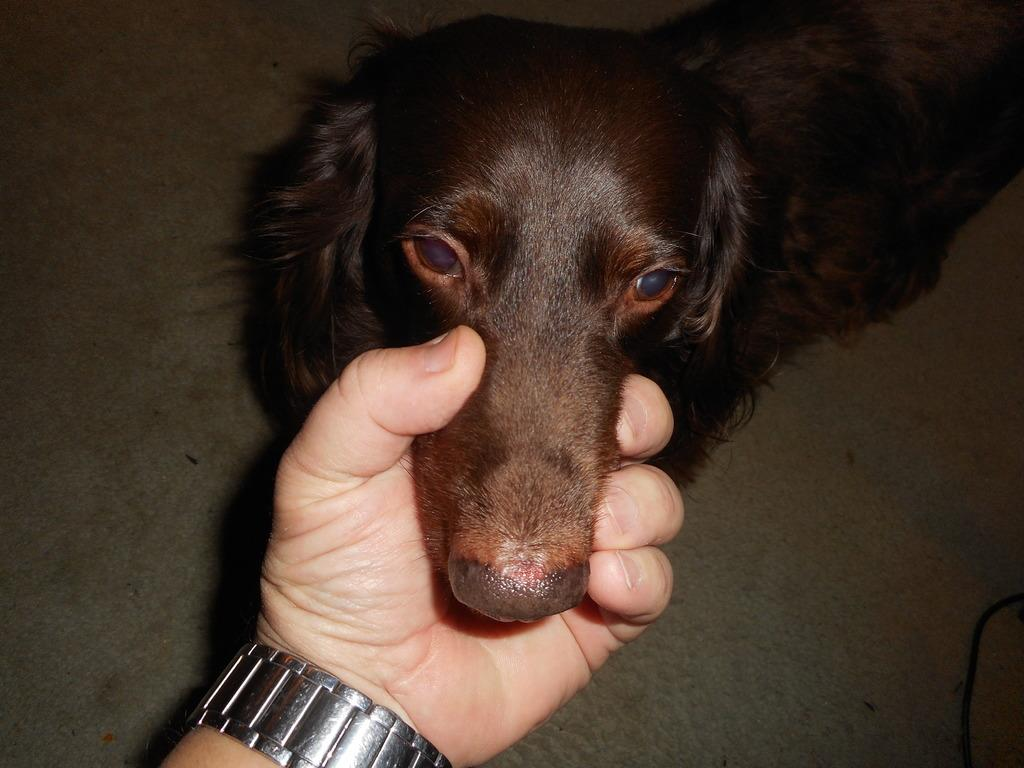What part of the human body is visible in the image? There is a human hand in the image. What object is also visible in the image? There is a watch in the image. What type of animal is present in the image? There is a black color dog in the image. What number is the judge suggesting in the image? There is no judge or suggestion of a number present in the image. What type of suggestion is the dog making in the image? There is no suggestion being made by the dog in the image. 